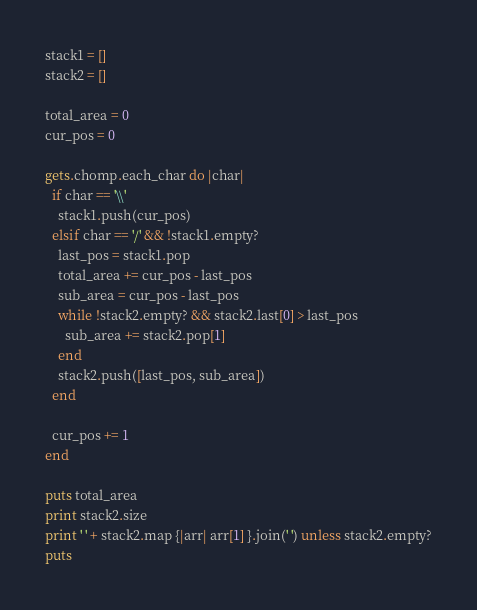Convert code to text. <code><loc_0><loc_0><loc_500><loc_500><_Ruby_>stack1 = []
stack2 = []

total_area = 0
cur_pos = 0

gets.chomp.each_char do |char|
  if char == '\\'
    stack1.push(cur_pos)
  elsif char == '/' && !stack1.empty?
    last_pos = stack1.pop
    total_area += cur_pos - last_pos
    sub_area = cur_pos - last_pos
    while !stack2.empty? && stack2.last[0] > last_pos
      sub_area += stack2.pop[1]
    end
    stack2.push([last_pos, sub_area])
  end

  cur_pos += 1
end

puts total_area
print stack2.size
print ' ' + stack2.map {|arr| arr[1] }.join(' ') unless stack2.empty?
puts</code> 